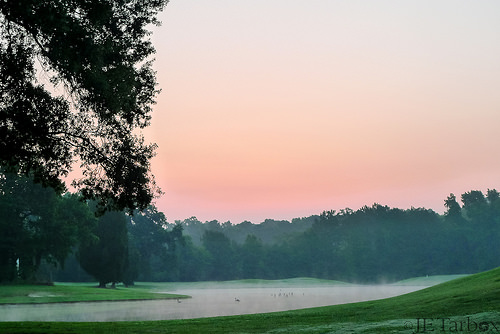<image>
Is there a grass next to the water? Yes. The grass is positioned adjacent to the water, located nearby in the same general area. 